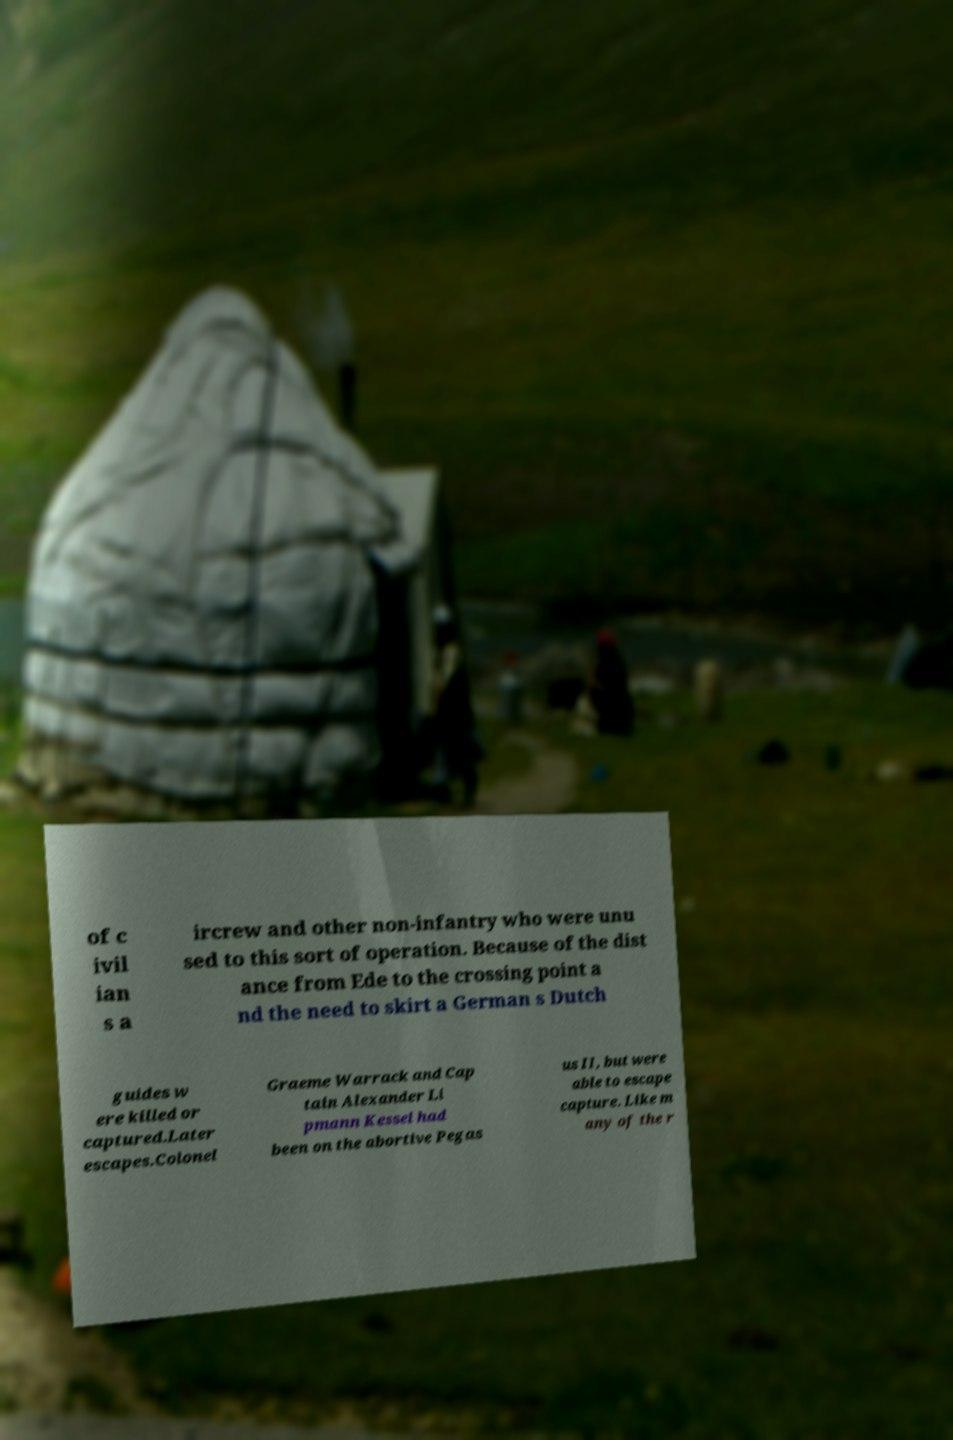Could you extract and type out the text from this image? of c ivil ian s a ircrew and other non-infantry who were unu sed to this sort of operation. Because of the dist ance from Ede to the crossing point a nd the need to skirt a German s Dutch guides w ere killed or captured.Later escapes.Colonel Graeme Warrack and Cap tain Alexander Li pmann Kessel had been on the abortive Pegas us II, but were able to escape capture. Like m any of the r 